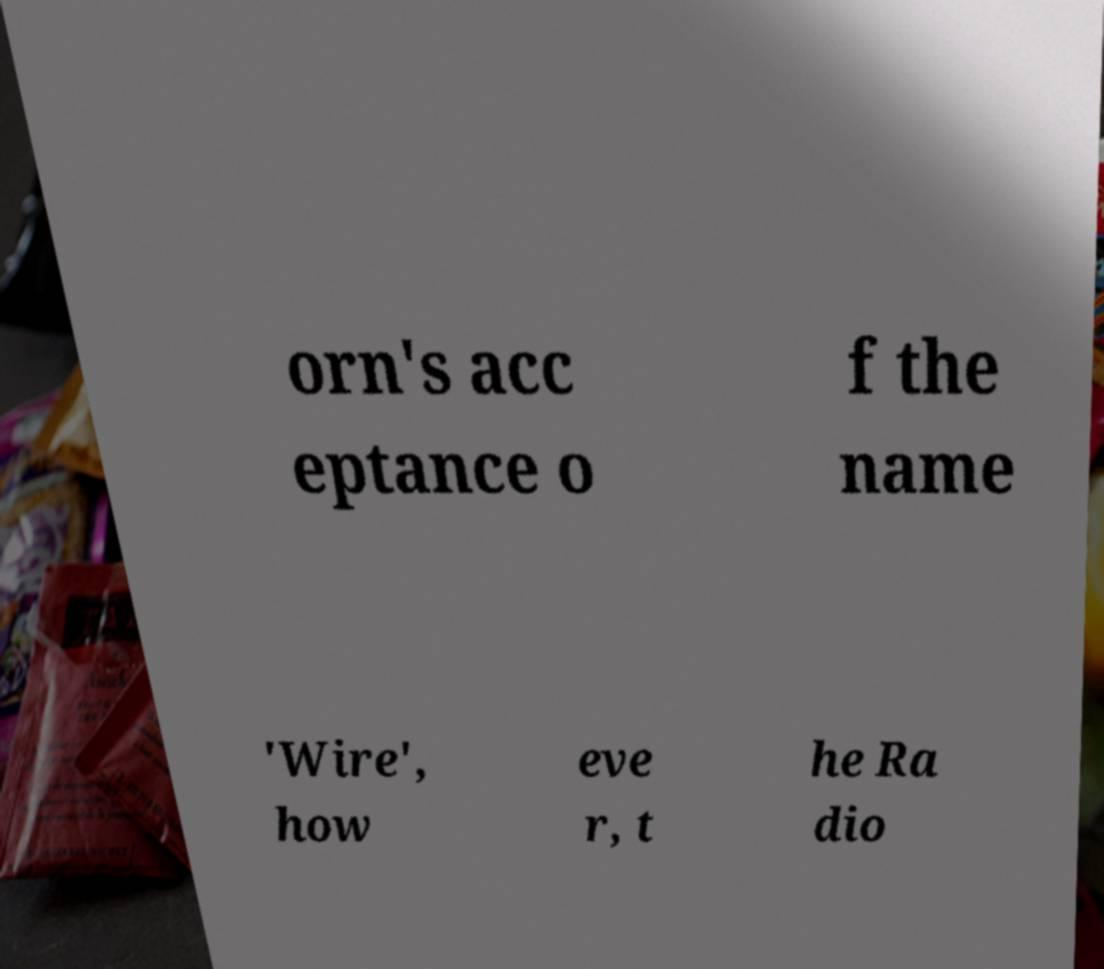Can you read and provide the text displayed in the image?This photo seems to have some interesting text. Can you extract and type it out for me? orn's acc eptance o f the name 'Wire', how eve r, t he Ra dio 